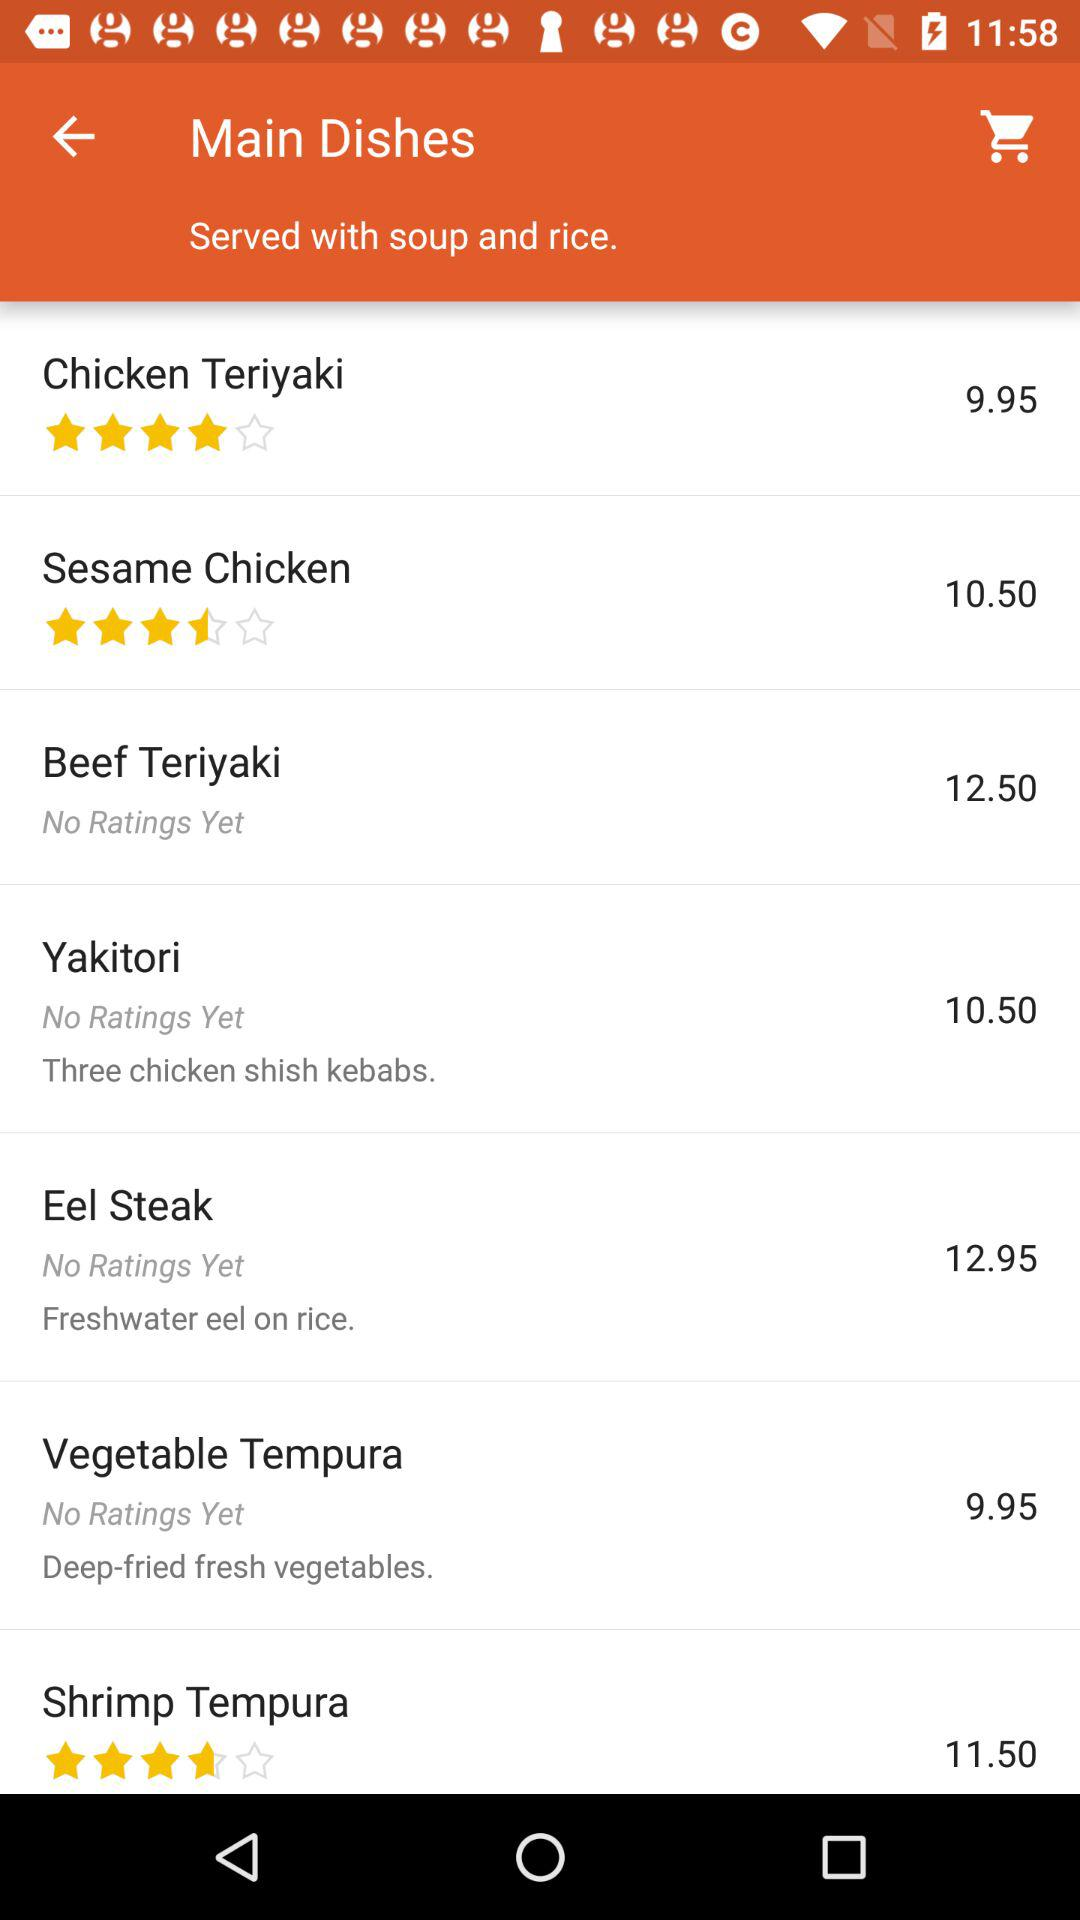What is the price of "Yakitori"? The price is 10.50. 